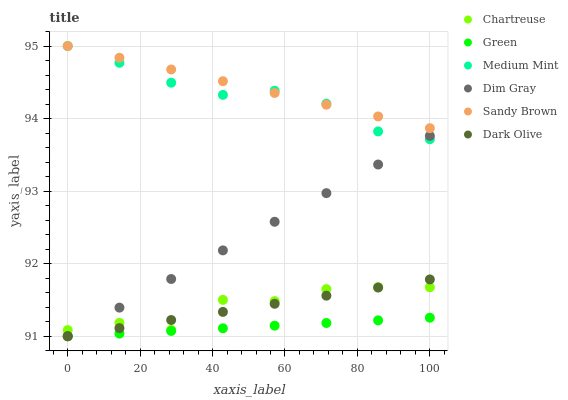Does Green have the minimum area under the curve?
Answer yes or no. Yes. Does Sandy Brown have the maximum area under the curve?
Answer yes or no. Yes. Does Dim Gray have the minimum area under the curve?
Answer yes or no. No. Does Dim Gray have the maximum area under the curve?
Answer yes or no. No. Is Sandy Brown the smoothest?
Answer yes or no. Yes. Is Chartreuse the roughest?
Answer yes or no. Yes. Is Dim Gray the smoothest?
Answer yes or no. No. Is Dim Gray the roughest?
Answer yes or no. No. Does Dim Gray have the lowest value?
Answer yes or no. Yes. Does Chartreuse have the lowest value?
Answer yes or no. No. Does Sandy Brown have the highest value?
Answer yes or no. Yes. Does Dim Gray have the highest value?
Answer yes or no. No. Is Dark Olive less than Sandy Brown?
Answer yes or no. Yes. Is Sandy Brown greater than Dark Olive?
Answer yes or no. Yes. Does Dim Gray intersect Dark Olive?
Answer yes or no. Yes. Is Dim Gray less than Dark Olive?
Answer yes or no. No. Is Dim Gray greater than Dark Olive?
Answer yes or no. No. Does Dark Olive intersect Sandy Brown?
Answer yes or no. No. 